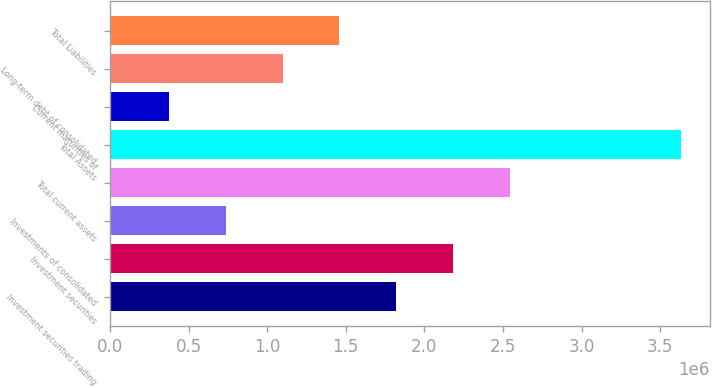Convert chart to OTSL. <chart><loc_0><loc_0><loc_500><loc_500><bar_chart><fcel>Investment securities trading<fcel>Investment securities<fcel>Investments of consolidated<fcel>Total current assets<fcel>Total Assets<fcel>Current maturities of<fcel>Long-term debt of consolidated<fcel>Total Liabilities<nl><fcel>1.82218e+06<fcel>2.18442e+06<fcel>735469<fcel>2.54666e+06<fcel>3.63337e+06<fcel>373231<fcel>1.09771e+06<fcel>1.45994e+06<nl></chart> 